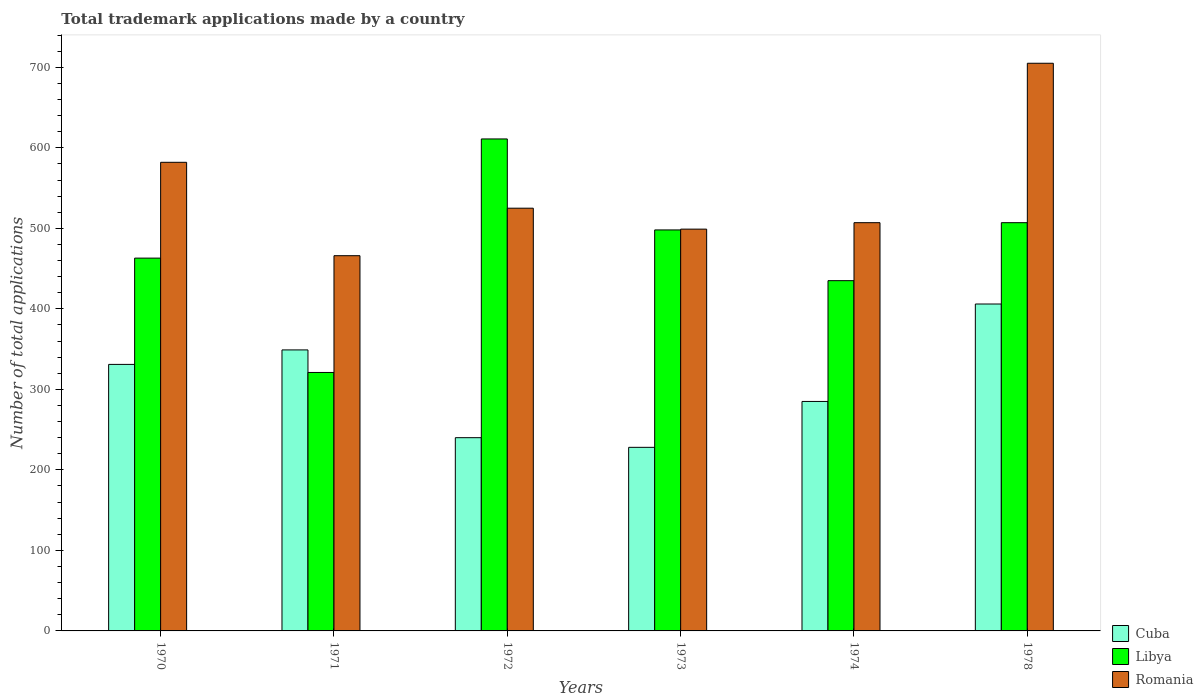In how many cases, is the number of bars for a given year not equal to the number of legend labels?
Ensure brevity in your answer.  0. What is the number of applications made by in Cuba in 1970?
Your answer should be very brief. 331. Across all years, what is the maximum number of applications made by in Libya?
Your answer should be very brief. 611. Across all years, what is the minimum number of applications made by in Libya?
Provide a succinct answer. 321. In which year was the number of applications made by in Romania maximum?
Keep it short and to the point. 1978. In which year was the number of applications made by in Cuba minimum?
Provide a short and direct response. 1973. What is the total number of applications made by in Libya in the graph?
Your answer should be compact. 2835. What is the difference between the number of applications made by in Cuba in 1971 and the number of applications made by in Romania in 1978?
Keep it short and to the point. -356. What is the average number of applications made by in Romania per year?
Offer a terse response. 547.33. In the year 1973, what is the difference between the number of applications made by in Romania and number of applications made by in Cuba?
Offer a terse response. 271. In how many years, is the number of applications made by in Libya greater than 720?
Keep it short and to the point. 0. What is the ratio of the number of applications made by in Romania in 1971 to that in 1978?
Offer a very short reply. 0.66. Is the number of applications made by in Libya in 1971 less than that in 1972?
Give a very brief answer. Yes. Is the difference between the number of applications made by in Romania in 1972 and 1978 greater than the difference between the number of applications made by in Cuba in 1972 and 1978?
Offer a terse response. No. What is the difference between the highest and the second highest number of applications made by in Libya?
Make the answer very short. 104. What is the difference between the highest and the lowest number of applications made by in Cuba?
Your answer should be very brief. 178. In how many years, is the number of applications made by in Romania greater than the average number of applications made by in Romania taken over all years?
Give a very brief answer. 2. Is the sum of the number of applications made by in Libya in 1972 and 1974 greater than the maximum number of applications made by in Romania across all years?
Ensure brevity in your answer.  Yes. What does the 3rd bar from the left in 1970 represents?
Your answer should be very brief. Romania. What does the 1st bar from the right in 1974 represents?
Keep it short and to the point. Romania. Is it the case that in every year, the sum of the number of applications made by in Cuba and number of applications made by in Libya is greater than the number of applications made by in Romania?
Your answer should be compact. Yes. How many bars are there?
Your answer should be compact. 18. How many years are there in the graph?
Offer a very short reply. 6. Does the graph contain any zero values?
Offer a very short reply. No. How are the legend labels stacked?
Your response must be concise. Vertical. What is the title of the graph?
Keep it short and to the point. Total trademark applications made by a country. What is the label or title of the Y-axis?
Provide a succinct answer. Number of total applications. What is the Number of total applications of Cuba in 1970?
Your response must be concise. 331. What is the Number of total applications in Libya in 1970?
Give a very brief answer. 463. What is the Number of total applications of Romania in 1970?
Offer a terse response. 582. What is the Number of total applications in Cuba in 1971?
Provide a short and direct response. 349. What is the Number of total applications of Libya in 1971?
Offer a terse response. 321. What is the Number of total applications of Romania in 1971?
Your answer should be compact. 466. What is the Number of total applications in Cuba in 1972?
Your answer should be compact. 240. What is the Number of total applications in Libya in 1972?
Provide a succinct answer. 611. What is the Number of total applications of Romania in 1972?
Offer a terse response. 525. What is the Number of total applications in Cuba in 1973?
Keep it short and to the point. 228. What is the Number of total applications in Libya in 1973?
Give a very brief answer. 498. What is the Number of total applications in Romania in 1973?
Provide a succinct answer. 499. What is the Number of total applications of Cuba in 1974?
Provide a succinct answer. 285. What is the Number of total applications in Libya in 1974?
Your answer should be compact. 435. What is the Number of total applications in Romania in 1974?
Offer a very short reply. 507. What is the Number of total applications of Cuba in 1978?
Your response must be concise. 406. What is the Number of total applications of Libya in 1978?
Provide a short and direct response. 507. What is the Number of total applications in Romania in 1978?
Keep it short and to the point. 705. Across all years, what is the maximum Number of total applications of Cuba?
Offer a terse response. 406. Across all years, what is the maximum Number of total applications in Libya?
Your response must be concise. 611. Across all years, what is the maximum Number of total applications of Romania?
Offer a terse response. 705. Across all years, what is the minimum Number of total applications of Cuba?
Your answer should be very brief. 228. Across all years, what is the minimum Number of total applications in Libya?
Offer a terse response. 321. Across all years, what is the minimum Number of total applications of Romania?
Your response must be concise. 466. What is the total Number of total applications of Cuba in the graph?
Your answer should be compact. 1839. What is the total Number of total applications of Libya in the graph?
Make the answer very short. 2835. What is the total Number of total applications in Romania in the graph?
Provide a succinct answer. 3284. What is the difference between the Number of total applications in Cuba in 1970 and that in 1971?
Offer a terse response. -18. What is the difference between the Number of total applications of Libya in 1970 and that in 1971?
Your response must be concise. 142. What is the difference between the Number of total applications in Romania in 1970 and that in 1971?
Make the answer very short. 116. What is the difference between the Number of total applications in Cuba in 1970 and that in 1972?
Offer a very short reply. 91. What is the difference between the Number of total applications of Libya in 1970 and that in 1972?
Provide a succinct answer. -148. What is the difference between the Number of total applications of Cuba in 1970 and that in 1973?
Provide a succinct answer. 103. What is the difference between the Number of total applications of Libya in 1970 and that in 1973?
Provide a short and direct response. -35. What is the difference between the Number of total applications in Romania in 1970 and that in 1973?
Ensure brevity in your answer.  83. What is the difference between the Number of total applications in Libya in 1970 and that in 1974?
Make the answer very short. 28. What is the difference between the Number of total applications of Cuba in 1970 and that in 1978?
Your response must be concise. -75. What is the difference between the Number of total applications of Libya in 1970 and that in 1978?
Your response must be concise. -44. What is the difference between the Number of total applications in Romania in 1970 and that in 1978?
Offer a very short reply. -123. What is the difference between the Number of total applications of Cuba in 1971 and that in 1972?
Make the answer very short. 109. What is the difference between the Number of total applications of Libya in 1971 and that in 1972?
Keep it short and to the point. -290. What is the difference between the Number of total applications of Romania in 1971 and that in 1972?
Provide a short and direct response. -59. What is the difference between the Number of total applications in Cuba in 1971 and that in 1973?
Keep it short and to the point. 121. What is the difference between the Number of total applications in Libya in 1971 and that in 1973?
Make the answer very short. -177. What is the difference between the Number of total applications of Romania in 1971 and that in 1973?
Provide a short and direct response. -33. What is the difference between the Number of total applications in Libya in 1971 and that in 1974?
Your answer should be compact. -114. What is the difference between the Number of total applications in Romania in 1971 and that in 1974?
Offer a very short reply. -41. What is the difference between the Number of total applications in Cuba in 1971 and that in 1978?
Your response must be concise. -57. What is the difference between the Number of total applications in Libya in 1971 and that in 1978?
Your response must be concise. -186. What is the difference between the Number of total applications of Romania in 1971 and that in 1978?
Ensure brevity in your answer.  -239. What is the difference between the Number of total applications in Libya in 1972 and that in 1973?
Offer a terse response. 113. What is the difference between the Number of total applications of Romania in 1972 and that in 1973?
Make the answer very short. 26. What is the difference between the Number of total applications of Cuba in 1972 and that in 1974?
Make the answer very short. -45. What is the difference between the Number of total applications in Libya in 1972 and that in 1974?
Offer a terse response. 176. What is the difference between the Number of total applications in Cuba in 1972 and that in 1978?
Your response must be concise. -166. What is the difference between the Number of total applications in Libya in 1972 and that in 1978?
Offer a very short reply. 104. What is the difference between the Number of total applications of Romania in 1972 and that in 1978?
Offer a very short reply. -180. What is the difference between the Number of total applications of Cuba in 1973 and that in 1974?
Provide a succinct answer. -57. What is the difference between the Number of total applications in Libya in 1973 and that in 1974?
Your answer should be compact. 63. What is the difference between the Number of total applications of Cuba in 1973 and that in 1978?
Your answer should be compact. -178. What is the difference between the Number of total applications in Romania in 1973 and that in 1978?
Give a very brief answer. -206. What is the difference between the Number of total applications of Cuba in 1974 and that in 1978?
Offer a very short reply. -121. What is the difference between the Number of total applications of Libya in 1974 and that in 1978?
Offer a very short reply. -72. What is the difference between the Number of total applications of Romania in 1974 and that in 1978?
Ensure brevity in your answer.  -198. What is the difference between the Number of total applications of Cuba in 1970 and the Number of total applications of Libya in 1971?
Keep it short and to the point. 10. What is the difference between the Number of total applications of Cuba in 1970 and the Number of total applications of Romania in 1971?
Provide a succinct answer. -135. What is the difference between the Number of total applications of Libya in 1970 and the Number of total applications of Romania in 1971?
Keep it short and to the point. -3. What is the difference between the Number of total applications in Cuba in 1970 and the Number of total applications in Libya in 1972?
Make the answer very short. -280. What is the difference between the Number of total applications in Cuba in 1970 and the Number of total applications in Romania in 1972?
Ensure brevity in your answer.  -194. What is the difference between the Number of total applications of Libya in 1970 and the Number of total applications of Romania in 1972?
Provide a short and direct response. -62. What is the difference between the Number of total applications in Cuba in 1970 and the Number of total applications in Libya in 1973?
Keep it short and to the point. -167. What is the difference between the Number of total applications in Cuba in 1970 and the Number of total applications in Romania in 1973?
Provide a succinct answer. -168. What is the difference between the Number of total applications of Libya in 1970 and the Number of total applications of Romania in 1973?
Ensure brevity in your answer.  -36. What is the difference between the Number of total applications in Cuba in 1970 and the Number of total applications in Libya in 1974?
Your answer should be compact. -104. What is the difference between the Number of total applications of Cuba in 1970 and the Number of total applications of Romania in 1974?
Make the answer very short. -176. What is the difference between the Number of total applications of Libya in 1970 and the Number of total applications of Romania in 1974?
Give a very brief answer. -44. What is the difference between the Number of total applications of Cuba in 1970 and the Number of total applications of Libya in 1978?
Your response must be concise. -176. What is the difference between the Number of total applications in Cuba in 1970 and the Number of total applications in Romania in 1978?
Ensure brevity in your answer.  -374. What is the difference between the Number of total applications of Libya in 1970 and the Number of total applications of Romania in 1978?
Provide a short and direct response. -242. What is the difference between the Number of total applications of Cuba in 1971 and the Number of total applications of Libya in 1972?
Provide a short and direct response. -262. What is the difference between the Number of total applications of Cuba in 1971 and the Number of total applications of Romania in 1972?
Keep it short and to the point. -176. What is the difference between the Number of total applications of Libya in 1971 and the Number of total applications of Romania in 1972?
Your response must be concise. -204. What is the difference between the Number of total applications in Cuba in 1971 and the Number of total applications in Libya in 1973?
Your answer should be compact. -149. What is the difference between the Number of total applications of Cuba in 1971 and the Number of total applications of Romania in 1973?
Ensure brevity in your answer.  -150. What is the difference between the Number of total applications of Libya in 1971 and the Number of total applications of Romania in 1973?
Your answer should be compact. -178. What is the difference between the Number of total applications in Cuba in 1971 and the Number of total applications in Libya in 1974?
Your answer should be very brief. -86. What is the difference between the Number of total applications in Cuba in 1971 and the Number of total applications in Romania in 1974?
Provide a short and direct response. -158. What is the difference between the Number of total applications of Libya in 1971 and the Number of total applications of Romania in 1974?
Offer a terse response. -186. What is the difference between the Number of total applications in Cuba in 1971 and the Number of total applications in Libya in 1978?
Provide a succinct answer. -158. What is the difference between the Number of total applications of Cuba in 1971 and the Number of total applications of Romania in 1978?
Offer a very short reply. -356. What is the difference between the Number of total applications in Libya in 1971 and the Number of total applications in Romania in 1978?
Your answer should be very brief. -384. What is the difference between the Number of total applications of Cuba in 1972 and the Number of total applications of Libya in 1973?
Offer a terse response. -258. What is the difference between the Number of total applications of Cuba in 1972 and the Number of total applications of Romania in 1973?
Give a very brief answer. -259. What is the difference between the Number of total applications in Libya in 1972 and the Number of total applications in Romania in 1973?
Offer a very short reply. 112. What is the difference between the Number of total applications of Cuba in 1972 and the Number of total applications of Libya in 1974?
Your answer should be compact. -195. What is the difference between the Number of total applications in Cuba in 1972 and the Number of total applications in Romania in 1974?
Keep it short and to the point. -267. What is the difference between the Number of total applications of Libya in 1972 and the Number of total applications of Romania in 1974?
Give a very brief answer. 104. What is the difference between the Number of total applications of Cuba in 1972 and the Number of total applications of Libya in 1978?
Give a very brief answer. -267. What is the difference between the Number of total applications of Cuba in 1972 and the Number of total applications of Romania in 1978?
Your answer should be very brief. -465. What is the difference between the Number of total applications of Libya in 1972 and the Number of total applications of Romania in 1978?
Offer a terse response. -94. What is the difference between the Number of total applications of Cuba in 1973 and the Number of total applications of Libya in 1974?
Keep it short and to the point. -207. What is the difference between the Number of total applications in Cuba in 1973 and the Number of total applications in Romania in 1974?
Offer a very short reply. -279. What is the difference between the Number of total applications of Libya in 1973 and the Number of total applications of Romania in 1974?
Your response must be concise. -9. What is the difference between the Number of total applications in Cuba in 1973 and the Number of total applications in Libya in 1978?
Provide a short and direct response. -279. What is the difference between the Number of total applications of Cuba in 1973 and the Number of total applications of Romania in 1978?
Make the answer very short. -477. What is the difference between the Number of total applications of Libya in 1973 and the Number of total applications of Romania in 1978?
Keep it short and to the point. -207. What is the difference between the Number of total applications of Cuba in 1974 and the Number of total applications of Libya in 1978?
Keep it short and to the point. -222. What is the difference between the Number of total applications of Cuba in 1974 and the Number of total applications of Romania in 1978?
Provide a succinct answer. -420. What is the difference between the Number of total applications in Libya in 1974 and the Number of total applications in Romania in 1978?
Give a very brief answer. -270. What is the average Number of total applications in Cuba per year?
Give a very brief answer. 306.5. What is the average Number of total applications in Libya per year?
Provide a succinct answer. 472.5. What is the average Number of total applications in Romania per year?
Make the answer very short. 547.33. In the year 1970, what is the difference between the Number of total applications of Cuba and Number of total applications of Libya?
Offer a terse response. -132. In the year 1970, what is the difference between the Number of total applications in Cuba and Number of total applications in Romania?
Give a very brief answer. -251. In the year 1970, what is the difference between the Number of total applications of Libya and Number of total applications of Romania?
Make the answer very short. -119. In the year 1971, what is the difference between the Number of total applications of Cuba and Number of total applications of Romania?
Your response must be concise. -117. In the year 1971, what is the difference between the Number of total applications in Libya and Number of total applications in Romania?
Provide a succinct answer. -145. In the year 1972, what is the difference between the Number of total applications of Cuba and Number of total applications of Libya?
Offer a very short reply. -371. In the year 1972, what is the difference between the Number of total applications of Cuba and Number of total applications of Romania?
Offer a terse response. -285. In the year 1972, what is the difference between the Number of total applications in Libya and Number of total applications in Romania?
Offer a terse response. 86. In the year 1973, what is the difference between the Number of total applications of Cuba and Number of total applications of Libya?
Ensure brevity in your answer.  -270. In the year 1973, what is the difference between the Number of total applications in Cuba and Number of total applications in Romania?
Make the answer very short. -271. In the year 1974, what is the difference between the Number of total applications in Cuba and Number of total applications in Libya?
Your response must be concise. -150. In the year 1974, what is the difference between the Number of total applications of Cuba and Number of total applications of Romania?
Keep it short and to the point. -222. In the year 1974, what is the difference between the Number of total applications of Libya and Number of total applications of Romania?
Offer a very short reply. -72. In the year 1978, what is the difference between the Number of total applications of Cuba and Number of total applications of Libya?
Ensure brevity in your answer.  -101. In the year 1978, what is the difference between the Number of total applications of Cuba and Number of total applications of Romania?
Offer a terse response. -299. In the year 1978, what is the difference between the Number of total applications of Libya and Number of total applications of Romania?
Keep it short and to the point. -198. What is the ratio of the Number of total applications in Cuba in 1970 to that in 1971?
Provide a short and direct response. 0.95. What is the ratio of the Number of total applications in Libya in 1970 to that in 1971?
Your answer should be compact. 1.44. What is the ratio of the Number of total applications in Romania in 1970 to that in 1971?
Your answer should be compact. 1.25. What is the ratio of the Number of total applications in Cuba in 1970 to that in 1972?
Your response must be concise. 1.38. What is the ratio of the Number of total applications of Libya in 1970 to that in 1972?
Your response must be concise. 0.76. What is the ratio of the Number of total applications of Romania in 1970 to that in 1972?
Give a very brief answer. 1.11. What is the ratio of the Number of total applications in Cuba in 1970 to that in 1973?
Give a very brief answer. 1.45. What is the ratio of the Number of total applications of Libya in 1970 to that in 1973?
Your answer should be very brief. 0.93. What is the ratio of the Number of total applications of Romania in 1970 to that in 1973?
Provide a short and direct response. 1.17. What is the ratio of the Number of total applications of Cuba in 1970 to that in 1974?
Your answer should be compact. 1.16. What is the ratio of the Number of total applications of Libya in 1970 to that in 1974?
Ensure brevity in your answer.  1.06. What is the ratio of the Number of total applications of Romania in 1970 to that in 1974?
Provide a short and direct response. 1.15. What is the ratio of the Number of total applications of Cuba in 1970 to that in 1978?
Keep it short and to the point. 0.82. What is the ratio of the Number of total applications in Libya in 1970 to that in 1978?
Keep it short and to the point. 0.91. What is the ratio of the Number of total applications in Romania in 1970 to that in 1978?
Give a very brief answer. 0.83. What is the ratio of the Number of total applications of Cuba in 1971 to that in 1972?
Provide a succinct answer. 1.45. What is the ratio of the Number of total applications in Libya in 1971 to that in 1972?
Make the answer very short. 0.53. What is the ratio of the Number of total applications in Romania in 1971 to that in 1972?
Ensure brevity in your answer.  0.89. What is the ratio of the Number of total applications of Cuba in 1971 to that in 1973?
Offer a terse response. 1.53. What is the ratio of the Number of total applications in Libya in 1971 to that in 1973?
Ensure brevity in your answer.  0.64. What is the ratio of the Number of total applications of Romania in 1971 to that in 1973?
Offer a very short reply. 0.93. What is the ratio of the Number of total applications in Cuba in 1971 to that in 1974?
Your answer should be compact. 1.22. What is the ratio of the Number of total applications in Libya in 1971 to that in 1974?
Offer a terse response. 0.74. What is the ratio of the Number of total applications of Romania in 1971 to that in 1974?
Provide a short and direct response. 0.92. What is the ratio of the Number of total applications in Cuba in 1971 to that in 1978?
Provide a succinct answer. 0.86. What is the ratio of the Number of total applications in Libya in 1971 to that in 1978?
Your response must be concise. 0.63. What is the ratio of the Number of total applications in Romania in 1971 to that in 1978?
Provide a short and direct response. 0.66. What is the ratio of the Number of total applications of Cuba in 1972 to that in 1973?
Offer a very short reply. 1.05. What is the ratio of the Number of total applications of Libya in 1972 to that in 1973?
Offer a very short reply. 1.23. What is the ratio of the Number of total applications of Romania in 1972 to that in 1973?
Keep it short and to the point. 1.05. What is the ratio of the Number of total applications in Cuba in 1972 to that in 1974?
Ensure brevity in your answer.  0.84. What is the ratio of the Number of total applications in Libya in 1972 to that in 1974?
Provide a short and direct response. 1.4. What is the ratio of the Number of total applications of Romania in 1972 to that in 1974?
Your response must be concise. 1.04. What is the ratio of the Number of total applications in Cuba in 1972 to that in 1978?
Your response must be concise. 0.59. What is the ratio of the Number of total applications in Libya in 1972 to that in 1978?
Your answer should be compact. 1.21. What is the ratio of the Number of total applications of Romania in 1972 to that in 1978?
Give a very brief answer. 0.74. What is the ratio of the Number of total applications of Libya in 1973 to that in 1974?
Provide a short and direct response. 1.14. What is the ratio of the Number of total applications of Romania in 1973 to that in 1974?
Provide a short and direct response. 0.98. What is the ratio of the Number of total applications in Cuba in 1973 to that in 1978?
Your response must be concise. 0.56. What is the ratio of the Number of total applications in Libya in 1973 to that in 1978?
Ensure brevity in your answer.  0.98. What is the ratio of the Number of total applications in Romania in 1973 to that in 1978?
Your response must be concise. 0.71. What is the ratio of the Number of total applications in Cuba in 1974 to that in 1978?
Keep it short and to the point. 0.7. What is the ratio of the Number of total applications in Libya in 1974 to that in 1978?
Your answer should be compact. 0.86. What is the ratio of the Number of total applications of Romania in 1974 to that in 1978?
Keep it short and to the point. 0.72. What is the difference between the highest and the second highest Number of total applications of Cuba?
Offer a terse response. 57. What is the difference between the highest and the second highest Number of total applications of Libya?
Offer a terse response. 104. What is the difference between the highest and the second highest Number of total applications in Romania?
Provide a short and direct response. 123. What is the difference between the highest and the lowest Number of total applications of Cuba?
Your answer should be very brief. 178. What is the difference between the highest and the lowest Number of total applications of Libya?
Your answer should be compact. 290. What is the difference between the highest and the lowest Number of total applications in Romania?
Provide a short and direct response. 239. 